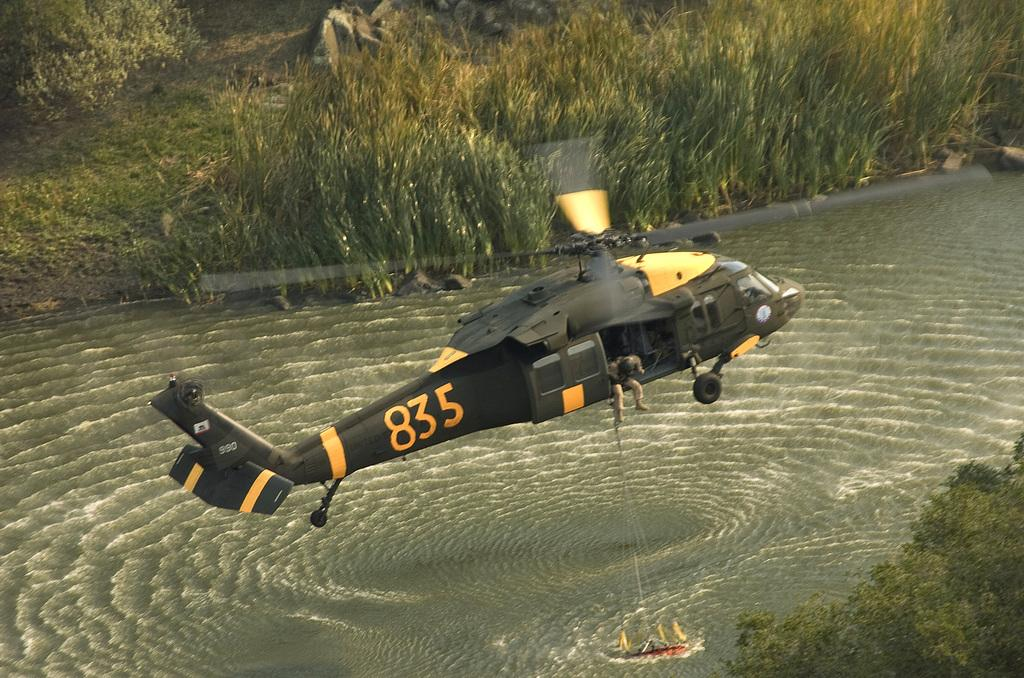What is the main subject of the picture? The main subject of the picture is a helicopter. What colors can be seen on the helicopter? The helicopter is black and yellow in color. What is the helicopter doing in the image? The helicopter is flying in the air. What type of landscape can be seen in the background? There is a large grassy area in the background. How many girls are playing baseball in the image? There are no girls or baseball game present in the image; it features a helicopter flying over a grassy area. 